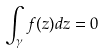Convert formula to latex. <formula><loc_0><loc_0><loc_500><loc_500>\int _ { \gamma } f ( z ) d z = 0</formula> 